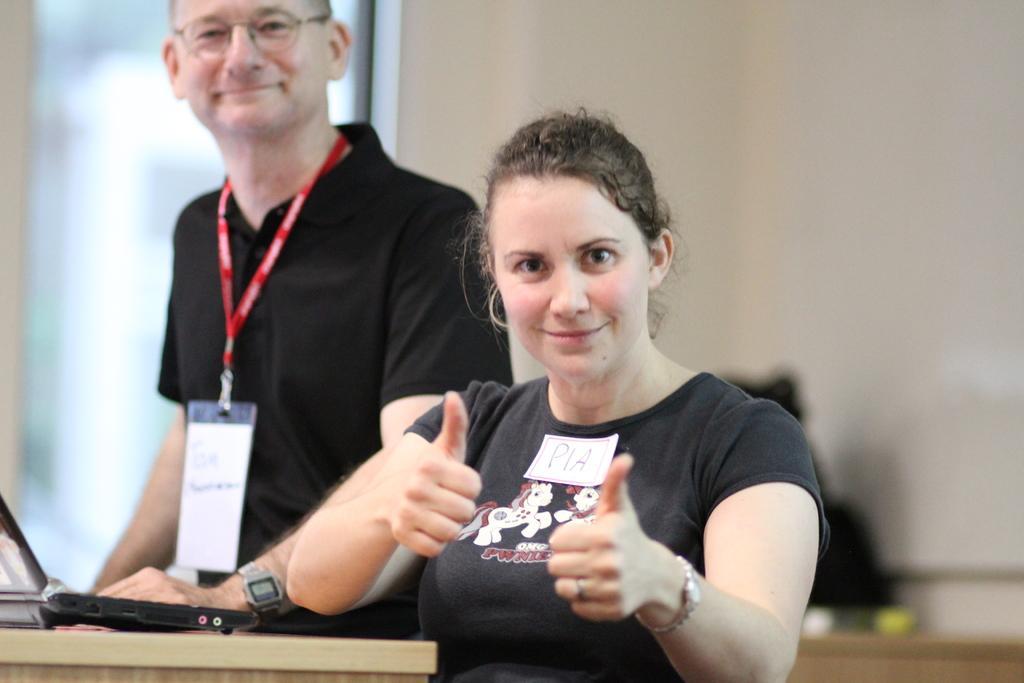Describe this image in one or two sentences. In this picture there are two people smiling and we can see laptop on the table. In the background of the image it is blurry. 